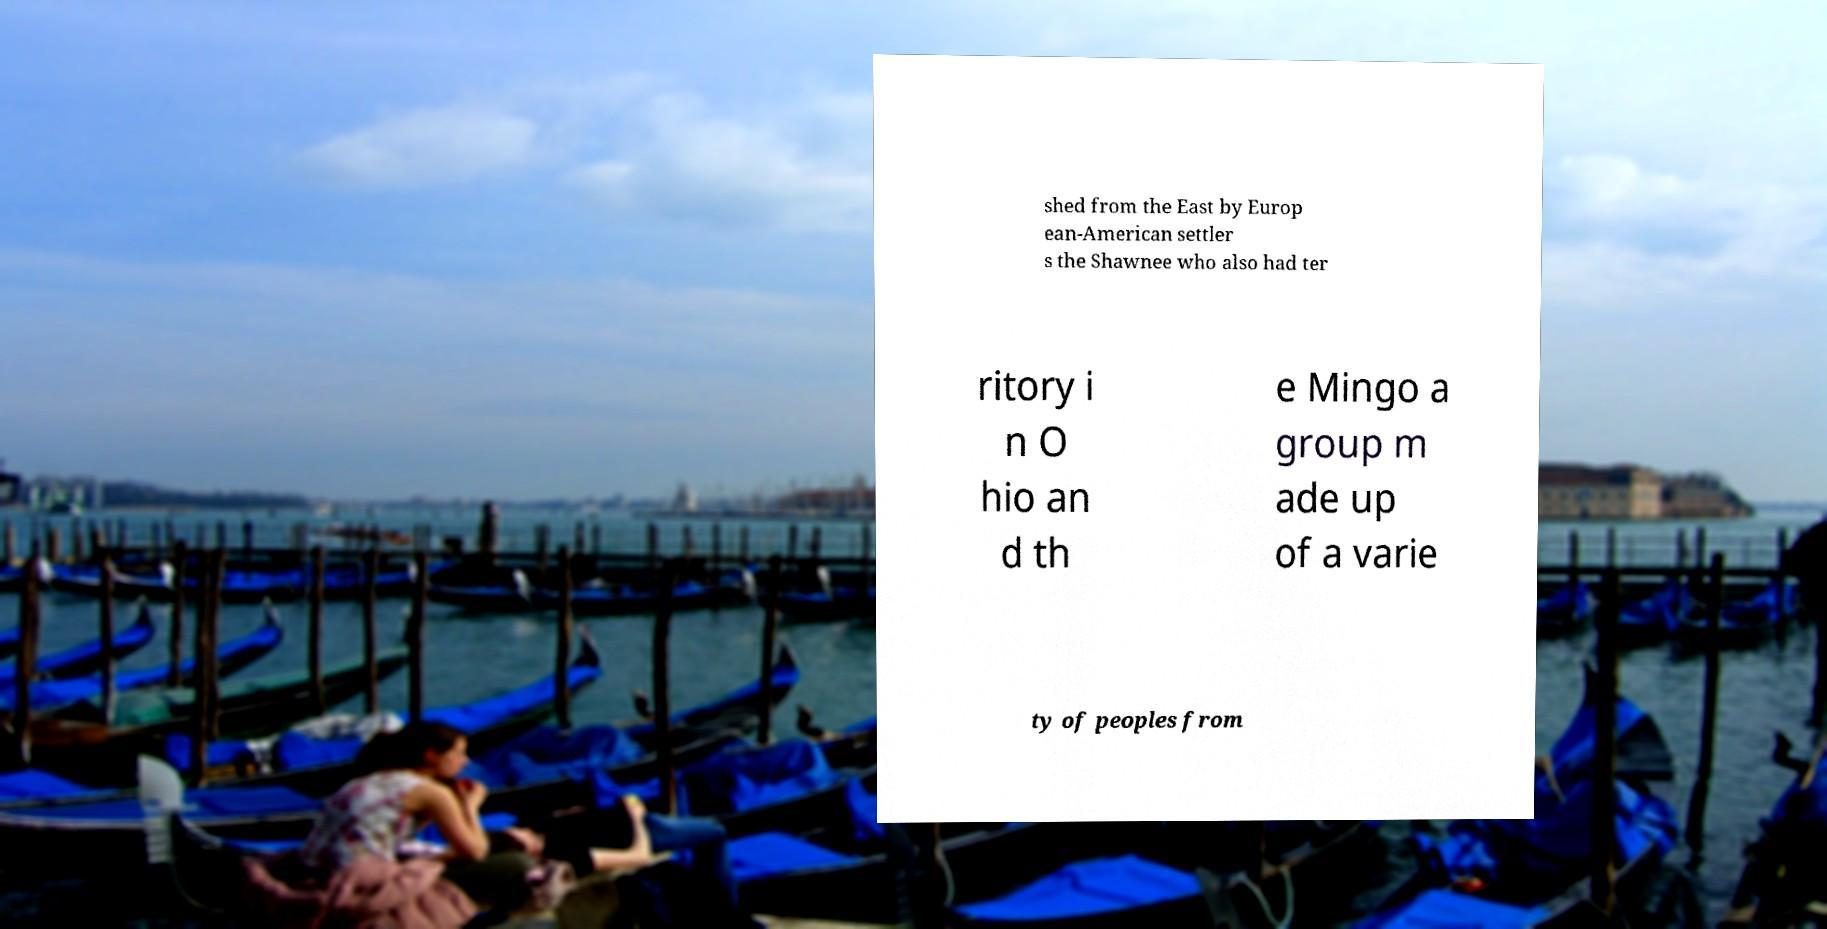Could you extract and type out the text from this image? shed from the East by Europ ean-American settler s the Shawnee who also had ter ritory i n O hio an d th e Mingo a group m ade up of a varie ty of peoples from 